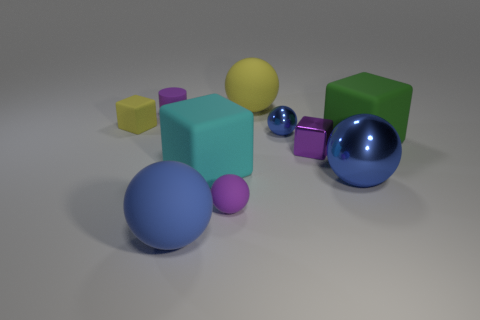How many other objects are there of the same color as the metal cube?
Keep it short and to the point. 2. There is a small rubber cube; is it the same color as the big rubber ball that is behind the purple metal block?
Make the answer very short. Yes. Do the large rubber ball that is behind the small purple cylinder and the block behind the tiny blue metal object have the same color?
Give a very brief answer. Yes. There is a small purple block that is right of the metal object behind the large green object; how many tiny purple spheres are in front of it?
Give a very brief answer. 1. What number of tiny purple rubber objects are both in front of the large cyan cube and on the left side of the blue rubber sphere?
Provide a short and direct response. 0. Is the number of tiny balls that are in front of the big metal sphere greater than the number of large brown blocks?
Give a very brief answer. Yes. What number of metal things are the same size as the purple rubber cylinder?
Offer a very short reply. 2. The other metallic ball that is the same color as the large metallic sphere is what size?
Offer a very short reply. Small. What number of large objects are either yellow metallic cylinders or matte cylinders?
Keep it short and to the point. 0. How many blue objects are there?
Offer a terse response. 3. 